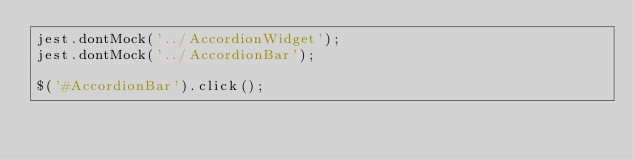<code> <loc_0><loc_0><loc_500><loc_500><_JavaScript_>jest.dontMock('../AccordionWidget');
jest.dontMock('../AccordionBar');

$('#AccordionBar').click();
</code> 